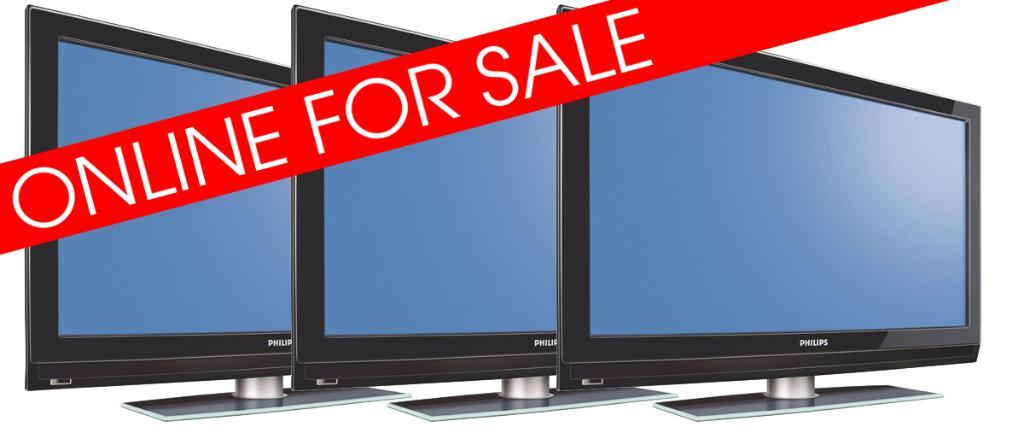<image>
Give a short and clear explanation of the subsequent image. Three Philips monitors that are available online for sale. 